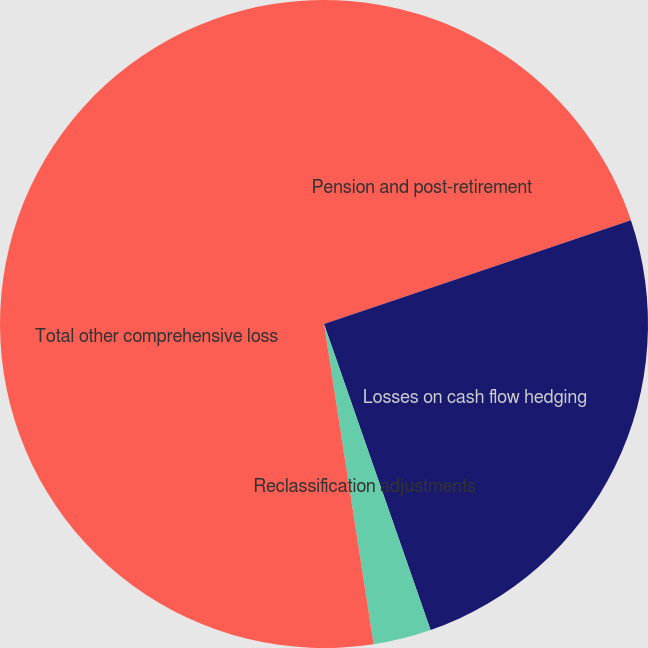Convert chart. <chart><loc_0><loc_0><loc_500><loc_500><pie_chart><fcel>Pension and post-retirement<fcel>Losses on cash flow hedging<fcel>Reclassification adjustments<fcel>Total other comprehensive loss<nl><fcel>19.81%<fcel>24.86%<fcel>2.89%<fcel>52.45%<nl></chart> 